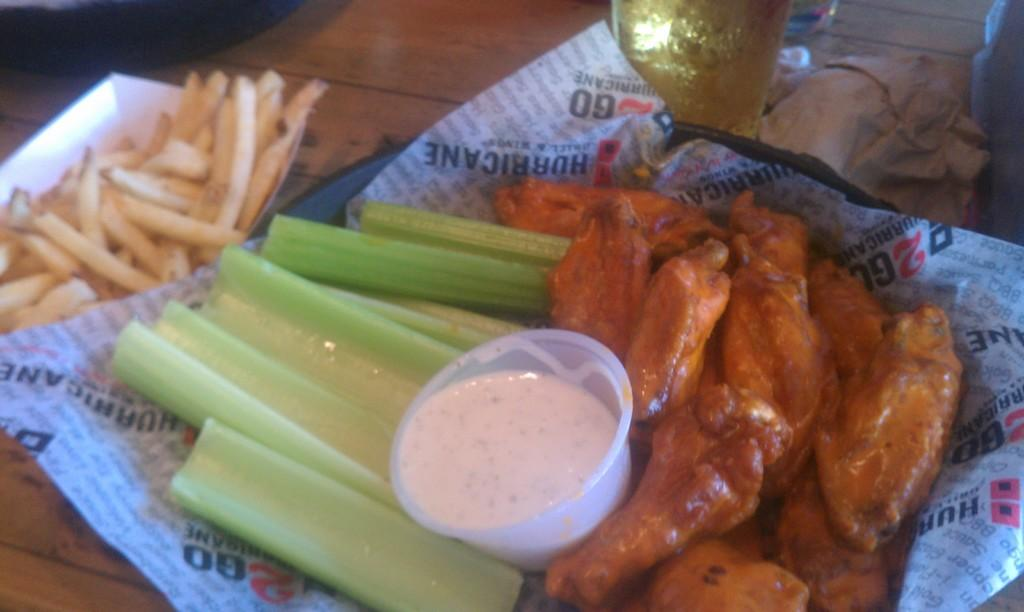What is present in the tray that is visible in the image? There are food items in a tray in the image. What type of container is holding sauce in the image? There is a cup with sauce in the image. What is written on the paper in the image? There is a paper with text in the image, but the specific text cannot be determined from the image. What else can be seen on the table in the image? There are other items placed on the table in the image, but their specific nature cannot be determined from the provided facts. What type of government is depicted in the image? There is no depiction of a government in the image; it features food items, a cup with sauce, a paper with text, and other items on a table. Where is the basin located in the image? There is no basin present in the image. 